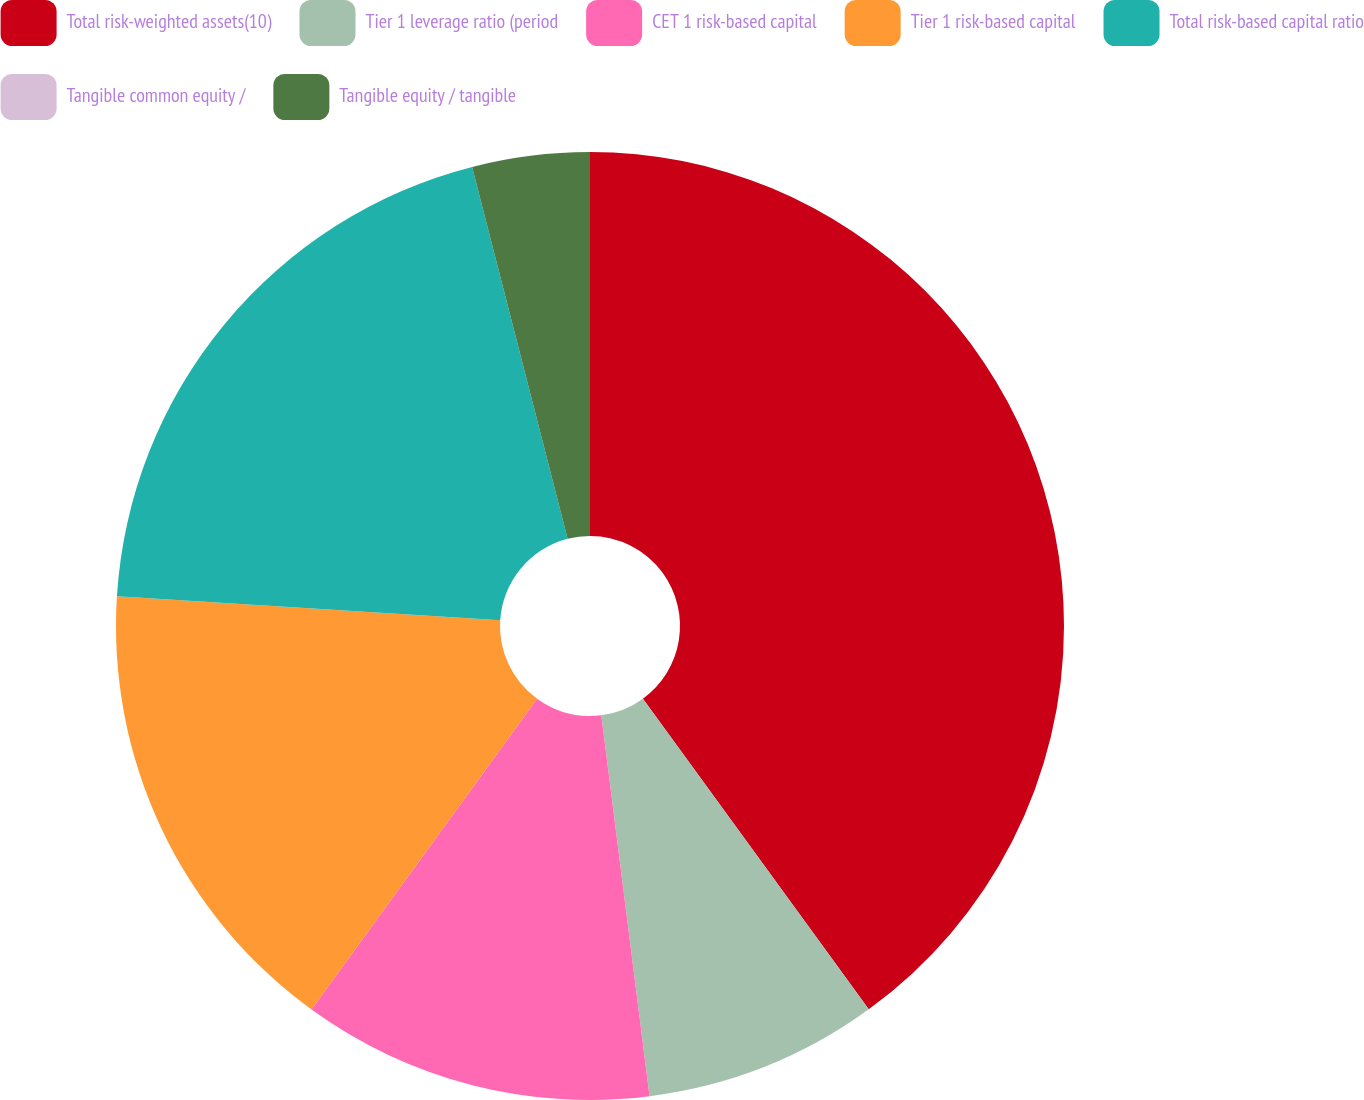Convert chart to OTSL. <chart><loc_0><loc_0><loc_500><loc_500><pie_chart><fcel>Total risk-weighted assets(10)<fcel>Tier 1 leverage ratio (period<fcel>CET 1 risk-based capital<fcel>Tier 1 risk-based capital<fcel>Total risk-based capital ratio<fcel>Tangible common equity /<fcel>Tangible equity / tangible<nl><fcel>39.99%<fcel>8.0%<fcel>12.0%<fcel>16.0%<fcel>20.0%<fcel>0.0%<fcel>4.0%<nl></chart> 